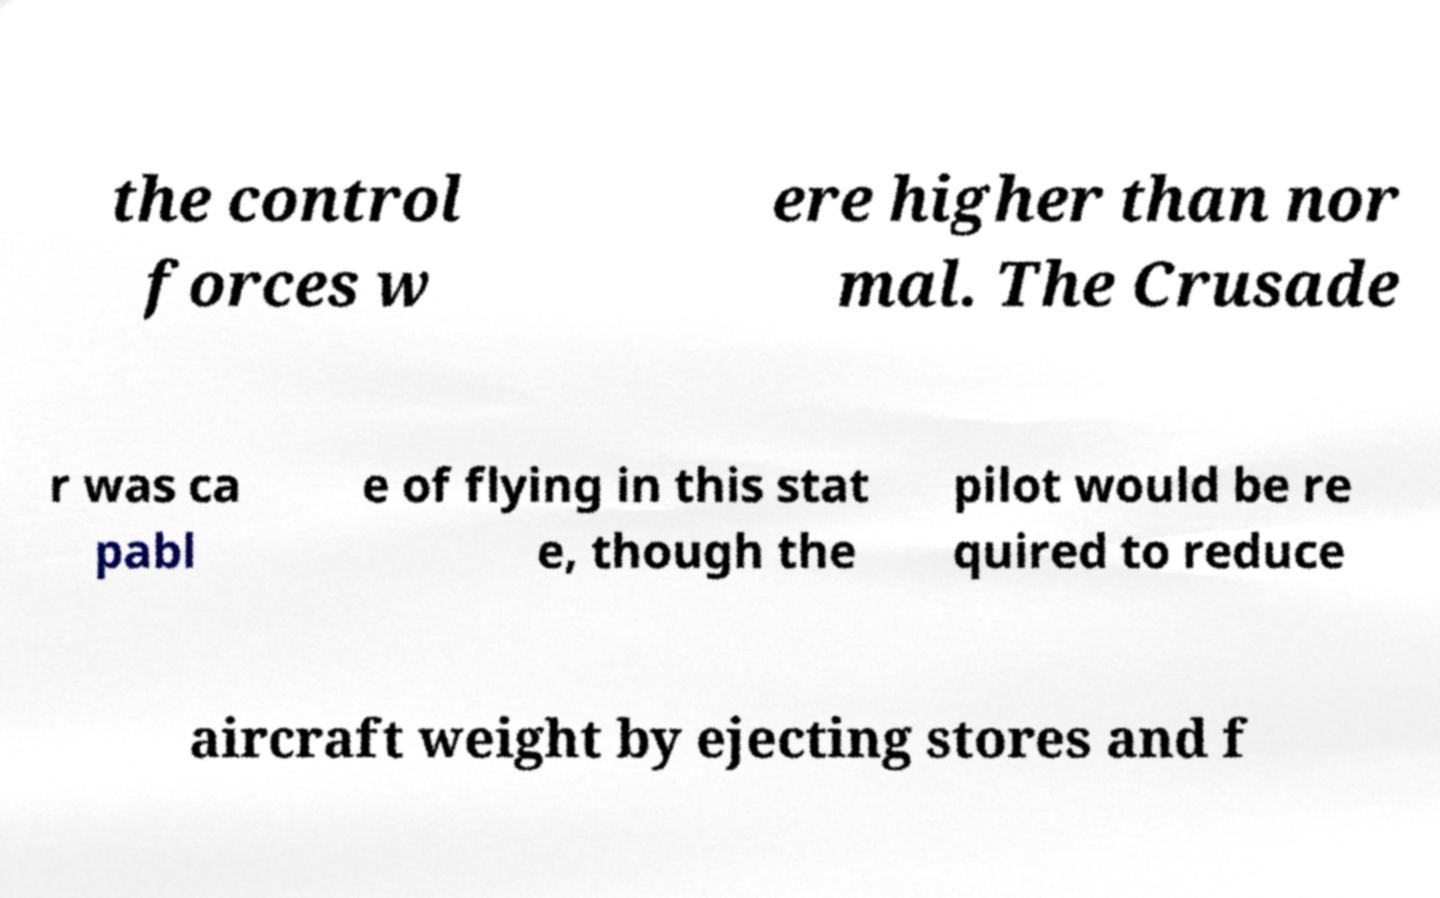There's text embedded in this image that I need extracted. Can you transcribe it verbatim? the control forces w ere higher than nor mal. The Crusade r was ca pabl e of flying in this stat e, though the pilot would be re quired to reduce aircraft weight by ejecting stores and f 